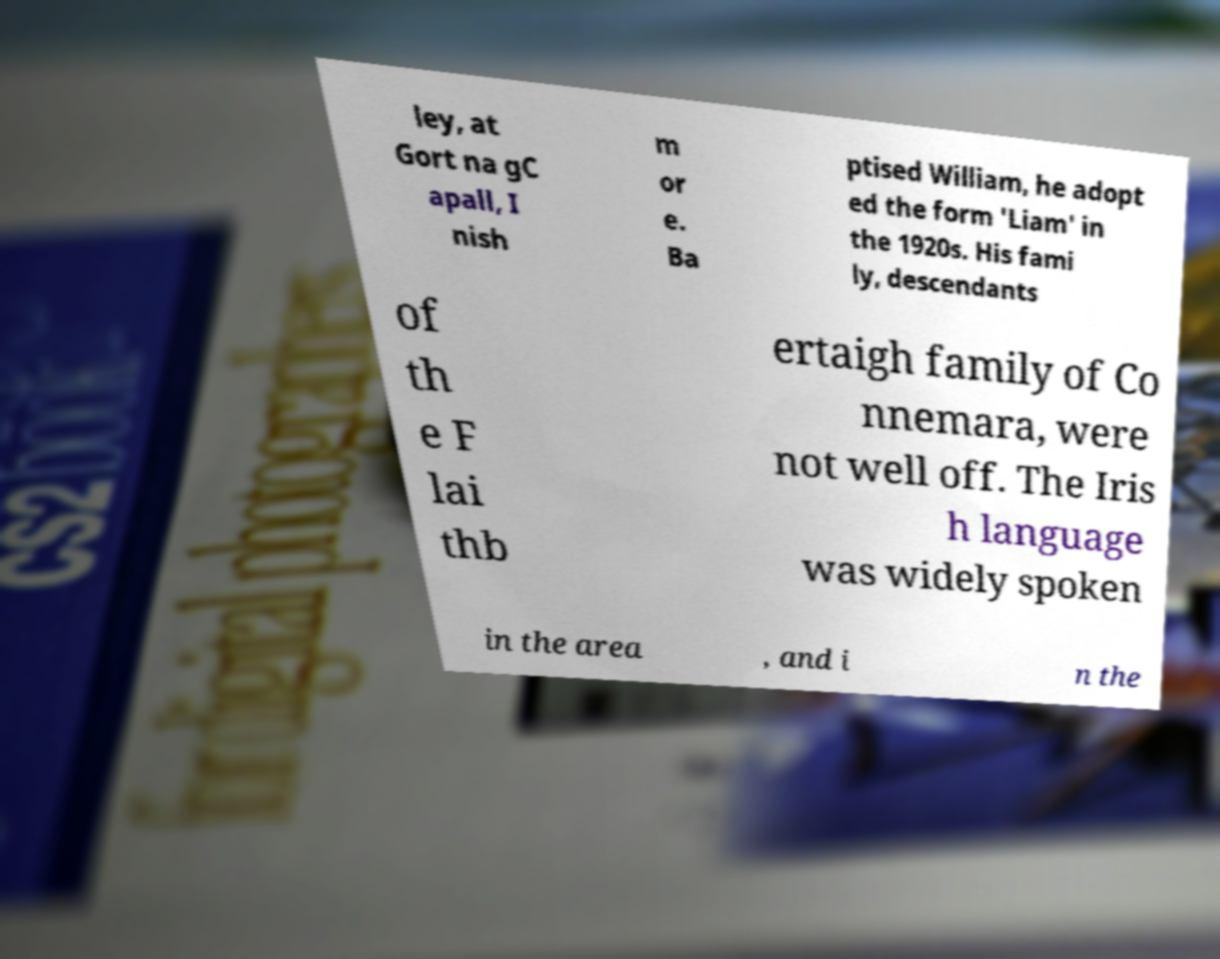Could you assist in decoding the text presented in this image and type it out clearly? ley, at Gort na gC apall, I nish m or e. Ba ptised William, he adopt ed the form 'Liam' in the 1920s. His fami ly, descendants of th e F lai thb ertaigh family of Co nnemara, were not well off. The Iris h language was widely spoken in the area , and i n the 